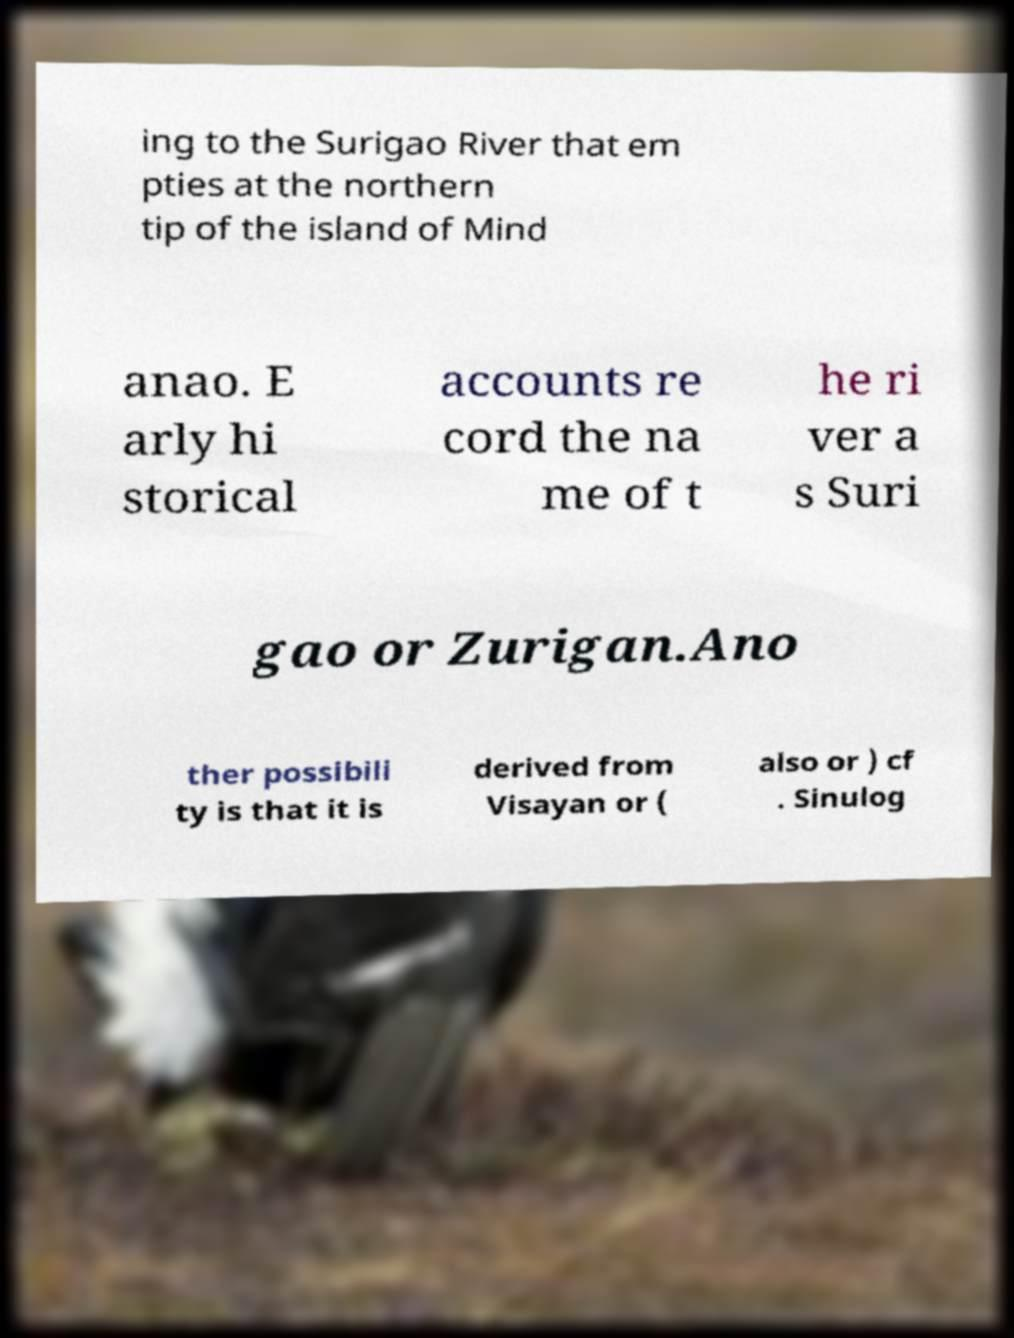Please read and relay the text visible in this image. What does it say? ing to the Surigao River that em pties at the northern tip of the island of Mind anao. E arly hi storical accounts re cord the na me of t he ri ver a s Suri gao or Zurigan.Ano ther possibili ty is that it is derived from Visayan or ( also or ) cf . Sinulog 